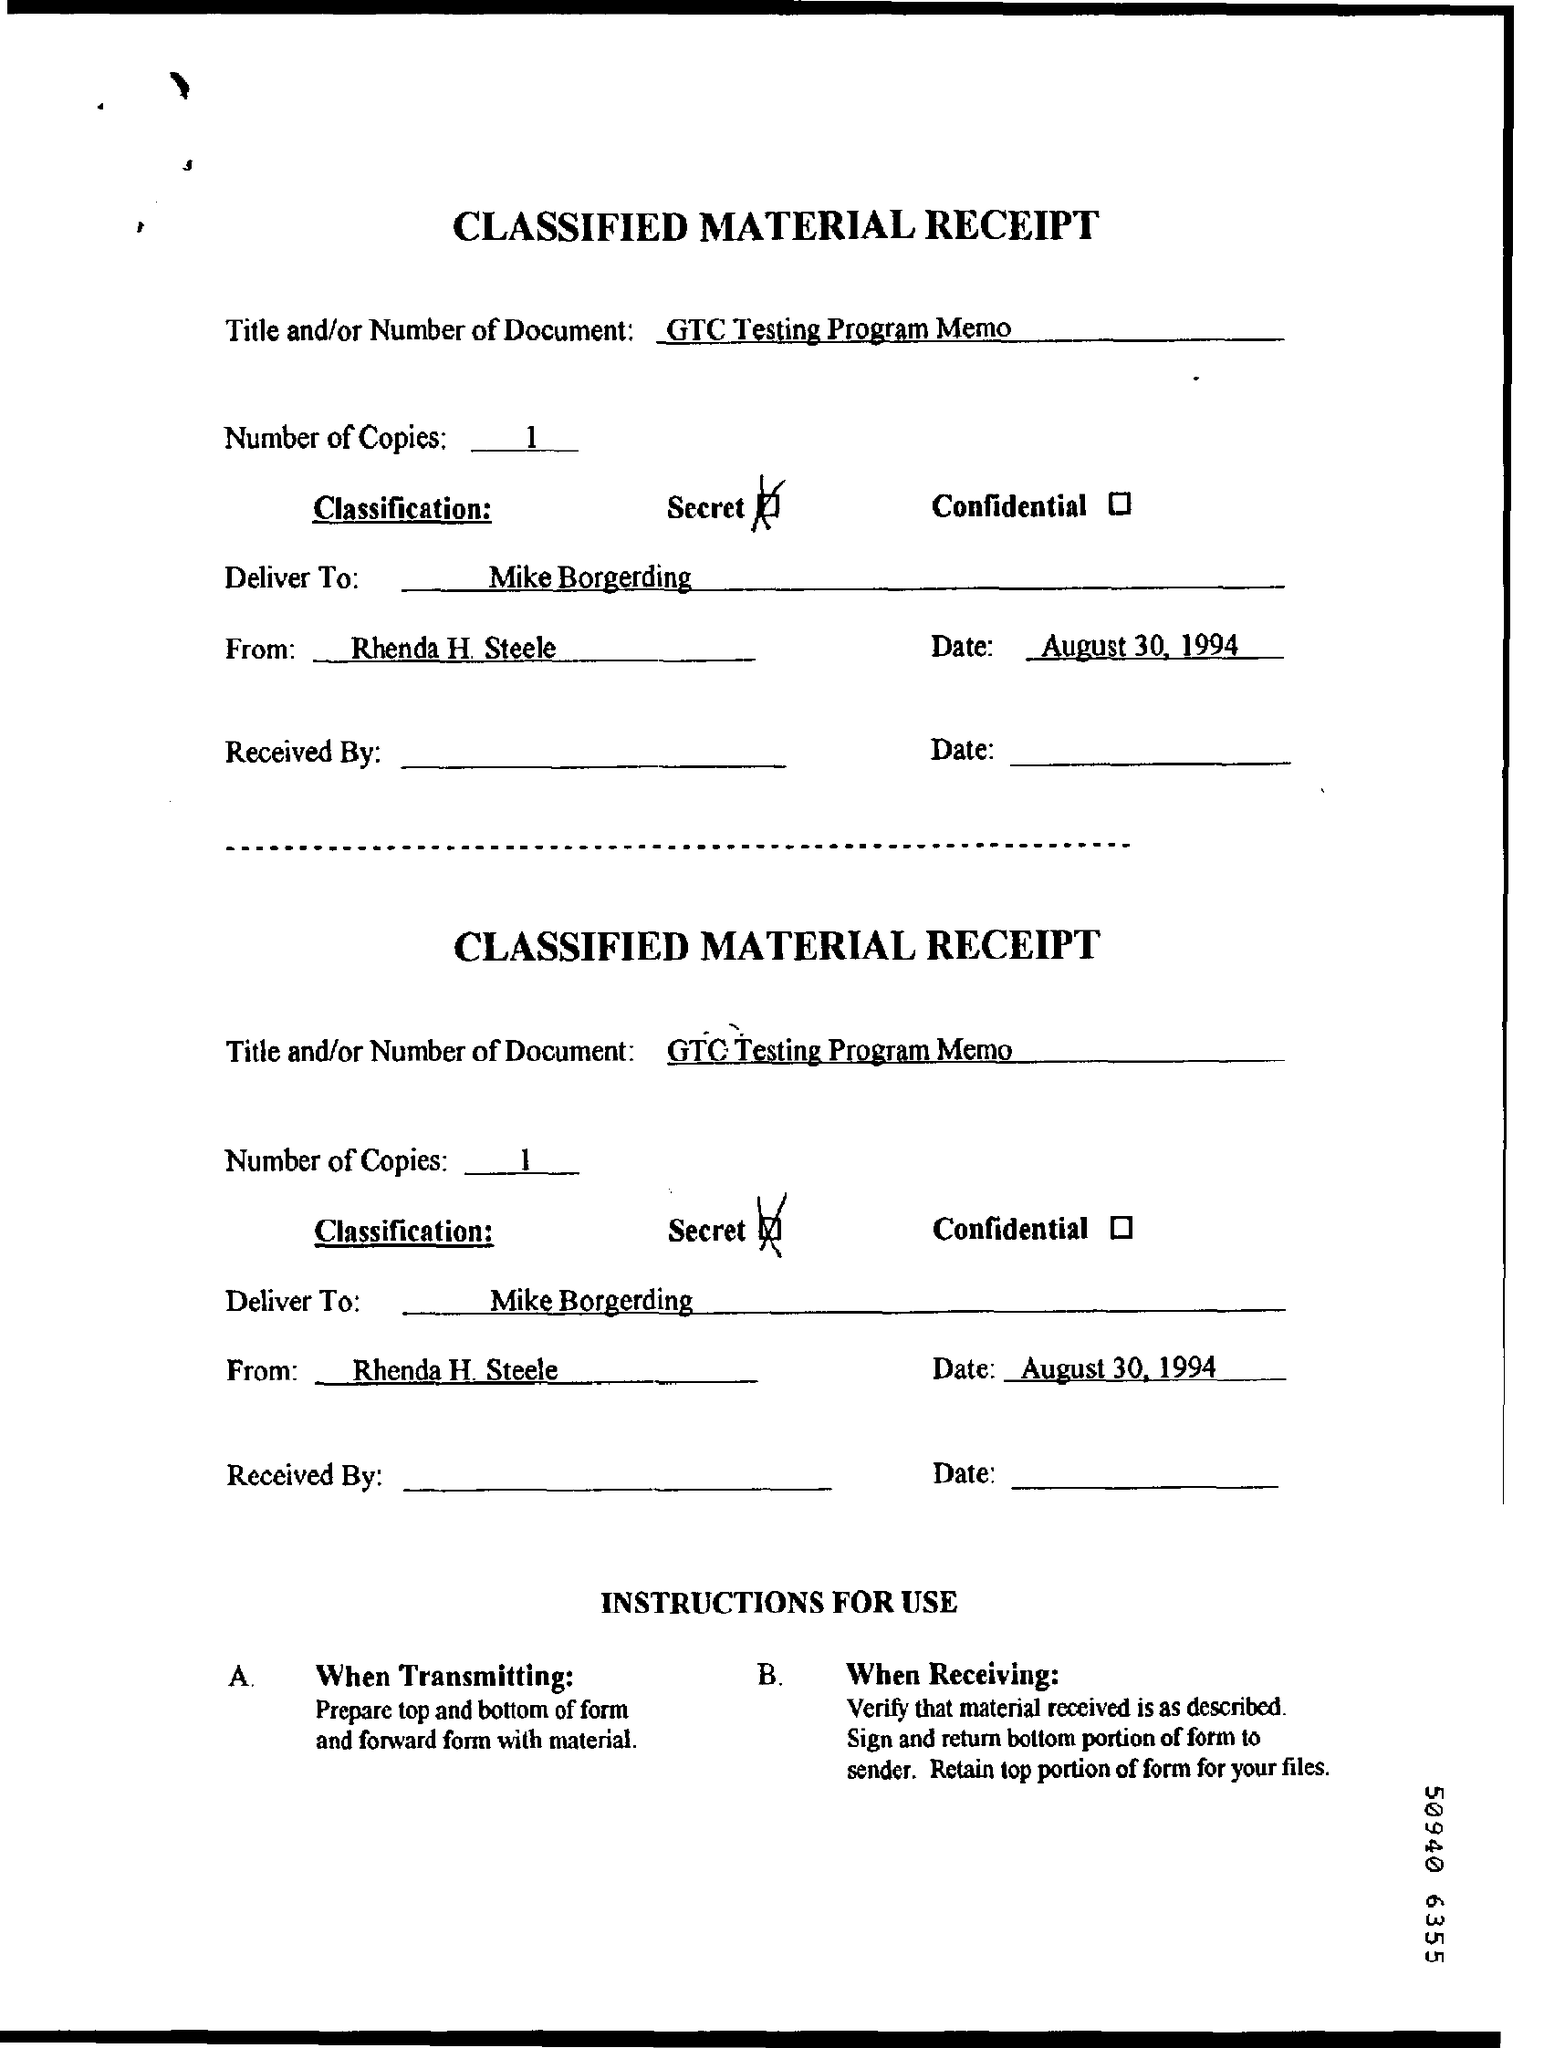Highlight a few significant elements in this photo. The memorandum is addressed to Mike Borgerding. August 30, 1994, is the date on which the Memorandum was issued. There is one copy and there will always be one copy. The memorandum is from Rhenda H Steele. 